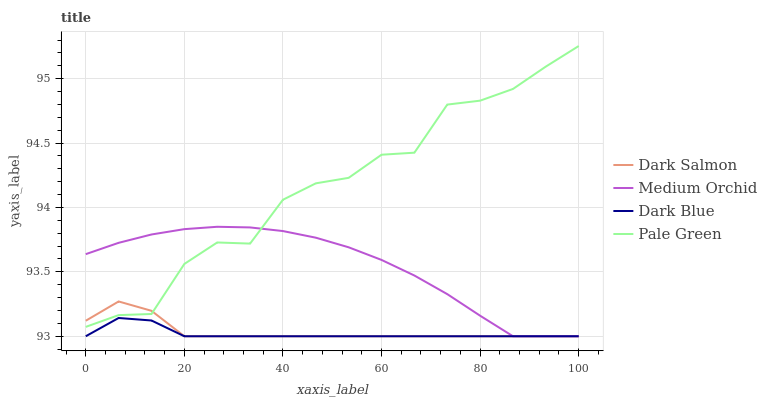Does Medium Orchid have the minimum area under the curve?
Answer yes or no. No. Does Medium Orchid have the maximum area under the curve?
Answer yes or no. No. Is Medium Orchid the smoothest?
Answer yes or no. No. Is Medium Orchid the roughest?
Answer yes or no. No. Does Pale Green have the lowest value?
Answer yes or no. No. Does Medium Orchid have the highest value?
Answer yes or no. No. Is Dark Blue less than Pale Green?
Answer yes or no. Yes. Is Pale Green greater than Dark Blue?
Answer yes or no. Yes. Does Dark Blue intersect Pale Green?
Answer yes or no. No. 